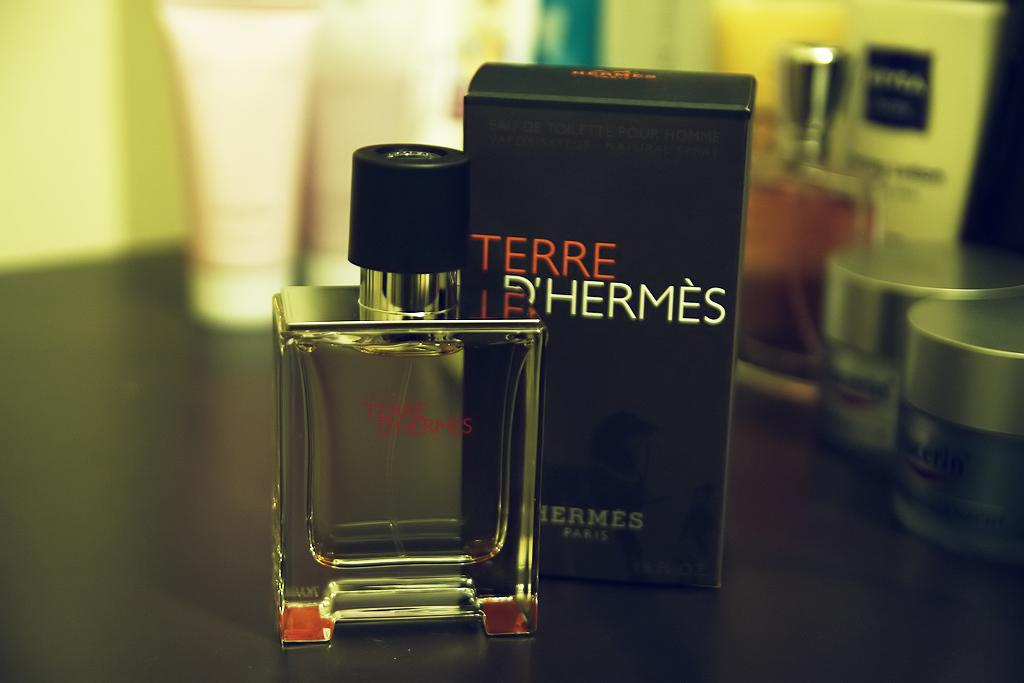<image>
Offer a succinct explanation of the picture presented. a bottle of Terre D'hermes perfume standing next to its box 